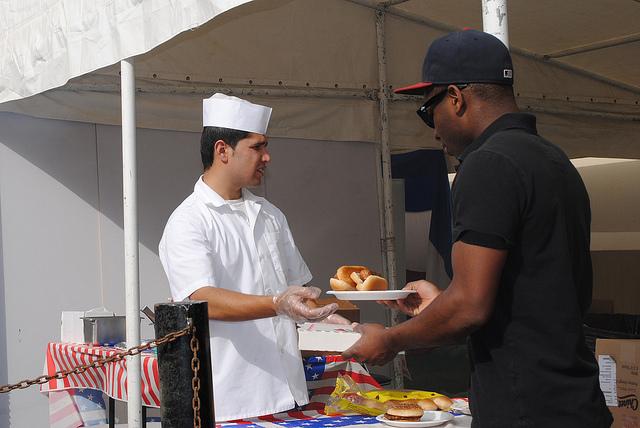Is there a shark in this restaurant?
Keep it brief. No. What holiday is it?
Write a very short answer. 4th of july. Is the dark guy wearing shades?
Write a very short answer. Yes. How many rolls is the man holding?
Be succinct. 2. Is this man looking for something?
Answer briefly. Yes. What is the man holding?
Give a very brief answer. Plate. What is in the oven?
Answer briefly. Hot dogs. What type of restaurant is this?
Keep it brief. American. 